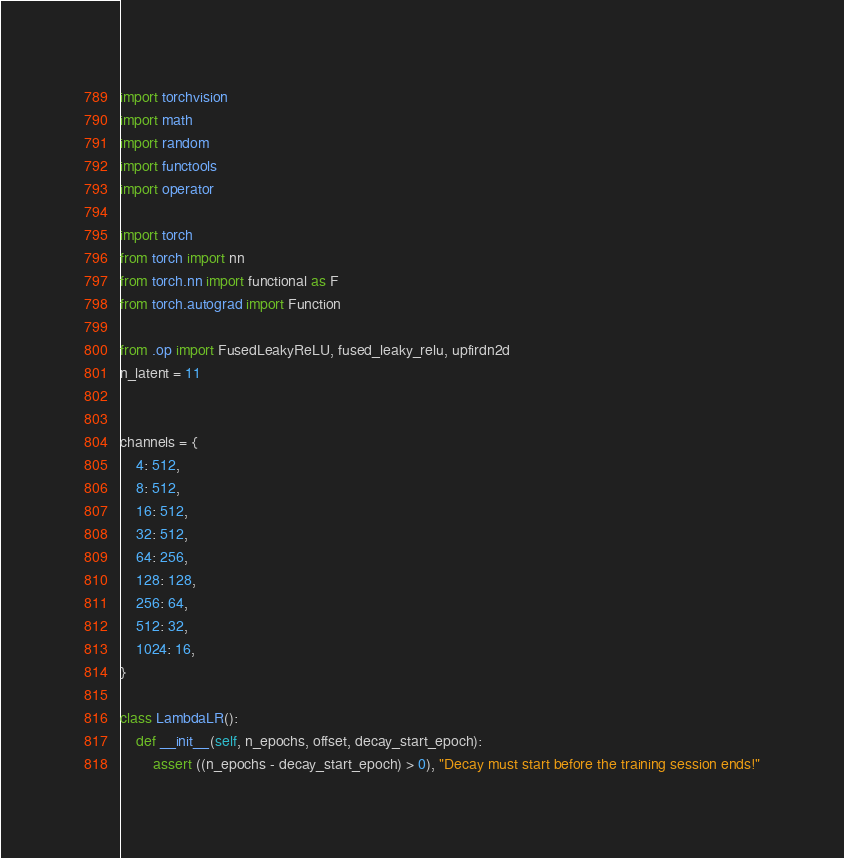<code> <loc_0><loc_0><loc_500><loc_500><_Python_>import torchvision
import math
import random
import functools
import operator

import torch
from torch import nn
from torch.nn import functional as F
from torch.autograd import Function

from .op import FusedLeakyReLU, fused_leaky_relu, upfirdn2d
n_latent = 11


channels = {
    4: 512,
    8: 512,
    16: 512,
    32: 512,
    64: 256,
    128: 128,
    256: 64,
    512: 32,
    1024: 16,
}

class LambdaLR():
    def __init__(self, n_epochs, offset, decay_start_epoch):
        assert ((n_epochs - decay_start_epoch) > 0), "Decay must start before the training session ends!"</code> 